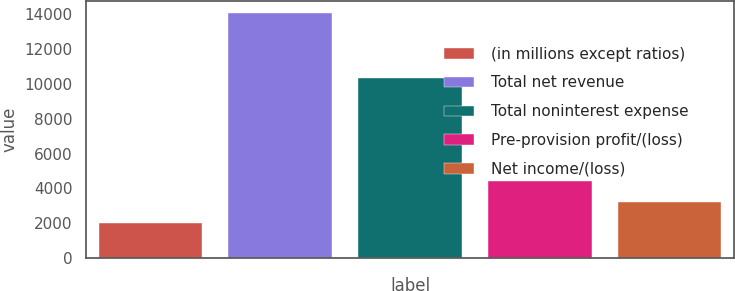Convert chart. <chart><loc_0><loc_0><loc_500><loc_500><bar_chart><fcel>(in millions except ratios)<fcel>Total net revenue<fcel>Total noninterest expense<fcel>Pre-provision profit/(loss)<fcel>Net income/(loss)<nl><fcel>2018<fcel>14076<fcel>10353<fcel>4429.6<fcel>3223.8<nl></chart> 